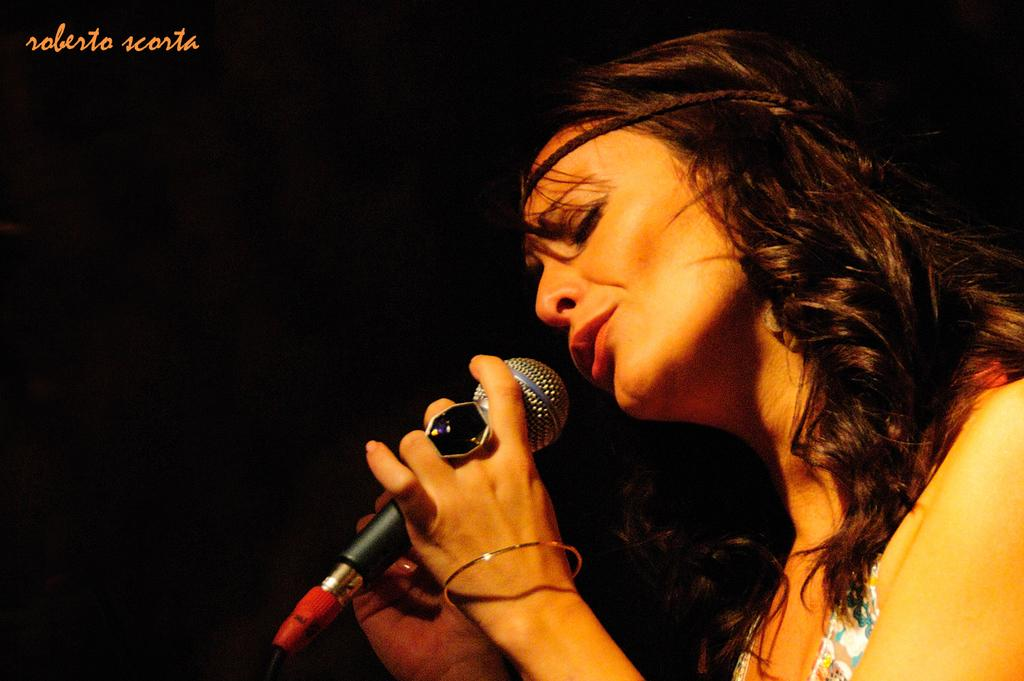Who is the main subject in the image? There is a woman in the image. What is the woman holding in her hand? The woman is holding a microphone in her hand. What is the woman doing in the image? The woman is singing. What can be seen in the left top corner of the image? There is text or an image in the left top corner of the image. What type of feast is being prepared in the image? There is no feast being prepared in the image; it features a woman singing while holding a microphone. Can you describe the waves in the image? There are no waves present in the image. 